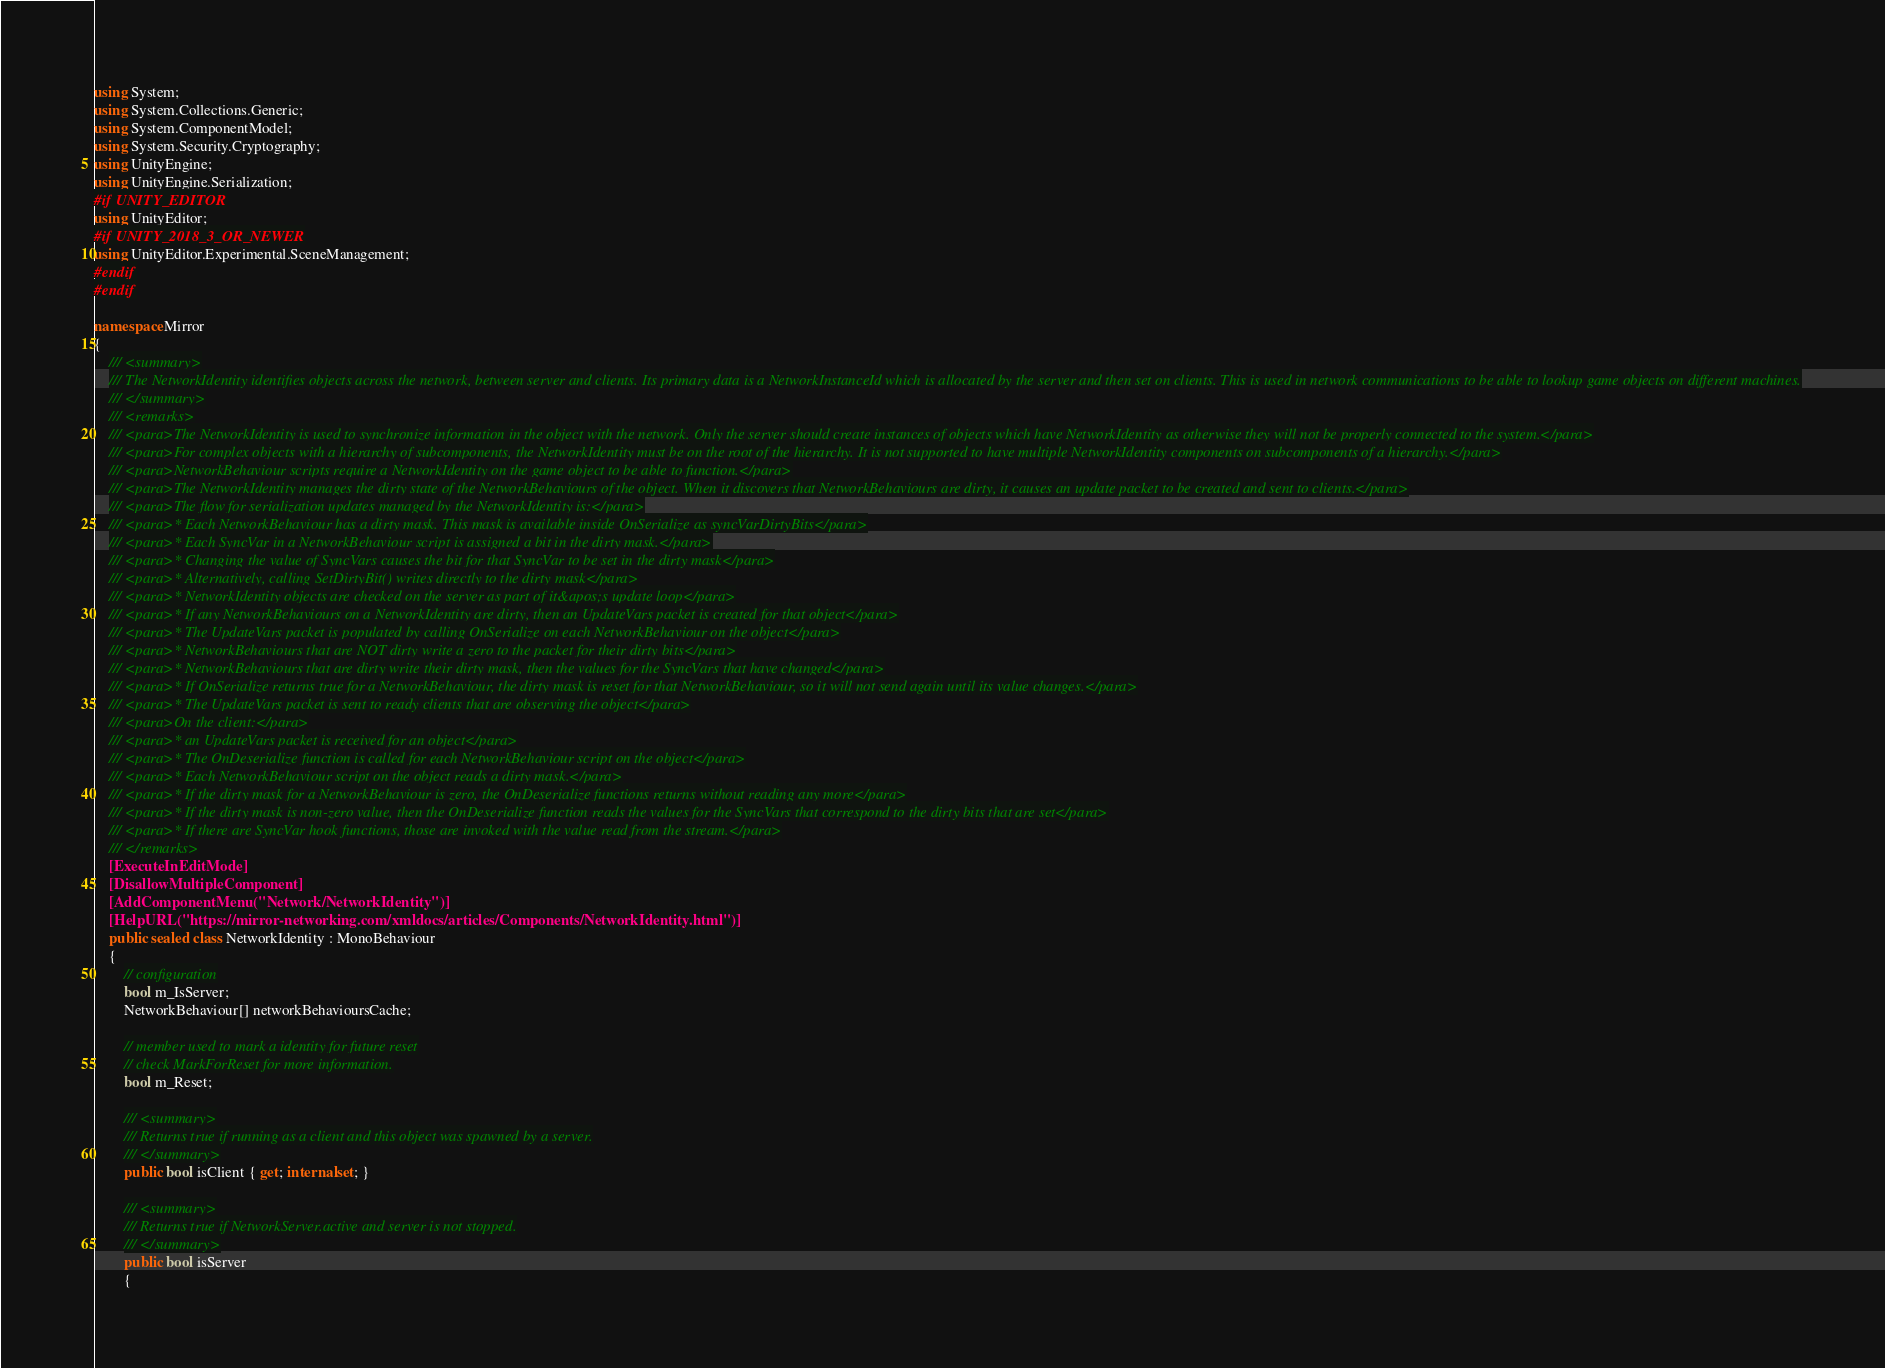<code> <loc_0><loc_0><loc_500><loc_500><_C#_>using System;
using System.Collections.Generic;
using System.ComponentModel;
using System.Security.Cryptography;
using UnityEngine;
using UnityEngine.Serialization;
#if UNITY_EDITOR
using UnityEditor;
#if UNITY_2018_3_OR_NEWER
using UnityEditor.Experimental.SceneManagement;
#endif
#endif

namespace Mirror
{
    /// <summary>
    /// The NetworkIdentity identifies objects across the network, between server and clients. Its primary data is a NetworkInstanceId which is allocated by the server and then set on clients. This is used in network communications to be able to lookup game objects on different machines.
    /// </summary>
    /// <remarks>
    /// <para>The NetworkIdentity is used to synchronize information in the object with the network. Only the server should create instances of objects which have NetworkIdentity as otherwise they will not be properly connected to the system.</para>
    /// <para>For complex objects with a hierarchy of subcomponents, the NetworkIdentity must be on the root of the hierarchy. It is not supported to have multiple NetworkIdentity components on subcomponents of a hierarchy.</para>
    /// <para>NetworkBehaviour scripts require a NetworkIdentity on the game object to be able to function.</para>
    /// <para>The NetworkIdentity manages the dirty state of the NetworkBehaviours of the object. When it discovers that NetworkBehaviours are dirty, it causes an update packet to be created and sent to clients.</para>
    /// <para>The flow for serialization updates managed by the NetworkIdentity is:</para>
    /// <para>* Each NetworkBehaviour has a dirty mask. This mask is available inside OnSerialize as syncVarDirtyBits</para>
    /// <para>* Each SyncVar in a NetworkBehaviour script is assigned a bit in the dirty mask.</para>
    /// <para>* Changing the value of SyncVars causes the bit for that SyncVar to be set in the dirty mask</para>
    /// <para>* Alternatively, calling SetDirtyBit() writes directly to the dirty mask</para>
    /// <para>* NetworkIdentity objects are checked on the server as part of it&apos;s update loop</para>
    /// <para>* If any NetworkBehaviours on a NetworkIdentity are dirty, then an UpdateVars packet is created for that object</para>
    /// <para>* The UpdateVars packet is populated by calling OnSerialize on each NetworkBehaviour on the object</para>
    /// <para>* NetworkBehaviours that are NOT dirty write a zero to the packet for their dirty bits</para>
    /// <para>* NetworkBehaviours that are dirty write their dirty mask, then the values for the SyncVars that have changed</para>
    /// <para>* If OnSerialize returns true for a NetworkBehaviour, the dirty mask is reset for that NetworkBehaviour, so it will not send again until its value changes.</para>
    /// <para>* The UpdateVars packet is sent to ready clients that are observing the object</para>
    /// <para>On the client:</para>
    /// <para>* an UpdateVars packet is received for an object</para>
    /// <para>* The OnDeserialize function is called for each NetworkBehaviour script on the object</para>
    /// <para>* Each NetworkBehaviour script on the object reads a dirty mask.</para>
    /// <para>* If the dirty mask for a NetworkBehaviour is zero, the OnDeserialize functions returns without reading any more</para>
    /// <para>* If the dirty mask is non-zero value, then the OnDeserialize function reads the values for the SyncVars that correspond to the dirty bits that are set</para>
    /// <para>* If there are SyncVar hook functions, those are invoked with the value read from the stream.</para>
    /// </remarks>
    [ExecuteInEditMode]
    [DisallowMultipleComponent]
    [AddComponentMenu("Network/NetworkIdentity")]
    [HelpURL("https://mirror-networking.com/xmldocs/articles/Components/NetworkIdentity.html")]
    public sealed class NetworkIdentity : MonoBehaviour
    {
        // configuration
        bool m_IsServer;
        NetworkBehaviour[] networkBehavioursCache;

        // member used to mark a identity for future reset
        // check MarkForReset for more information.
        bool m_Reset;

        /// <summary>
        /// Returns true if running as a client and this object was spawned by a server.
        /// </summary>
        public bool isClient { get; internal set; }

        /// <summary>
        /// Returns true if NetworkServer.active and server is not stopped.
        /// </summary>
        public bool isServer
        {</code> 